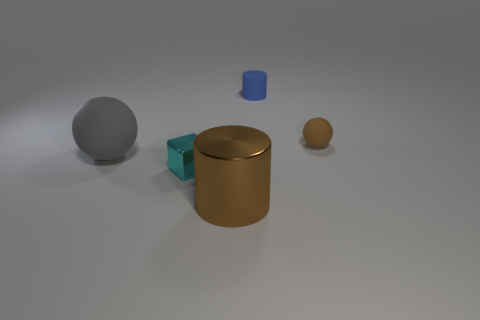How many other objects are the same size as the metallic cylinder?
Provide a succinct answer. 1. How many objects are either big balls or rubber things behind the small brown object?
Your answer should be very brief. 2. Is the number of metallic cylinders that are to the left of the large gray matte sphere the same as the number of blue objects?
Offer a terse response. No. There is another big object that is the same material as the cyan object; what is its shape?
Provide a short and direct response. Cylinder. Is there another small metallic cube that has the same color as the block?
Offer a very short reply. No. What number of metal objects are either blue things or green things?
Make the answer very short. 0. What number of small rubber cylinders are left of the brown object that is behind the brown cylinder?
Offer a very short reply. 1. What number of large brown cylinders are the same material as the cyan thing?
Your answer should be very brief. 1. How many big things are either yellow spheres or blue cylinders?
Keep it short and to the point. 0. What is the shape of the thing that is both on the right side of the cyan block and in front of the big gray object?
Offer a terse response. Cylinder. 